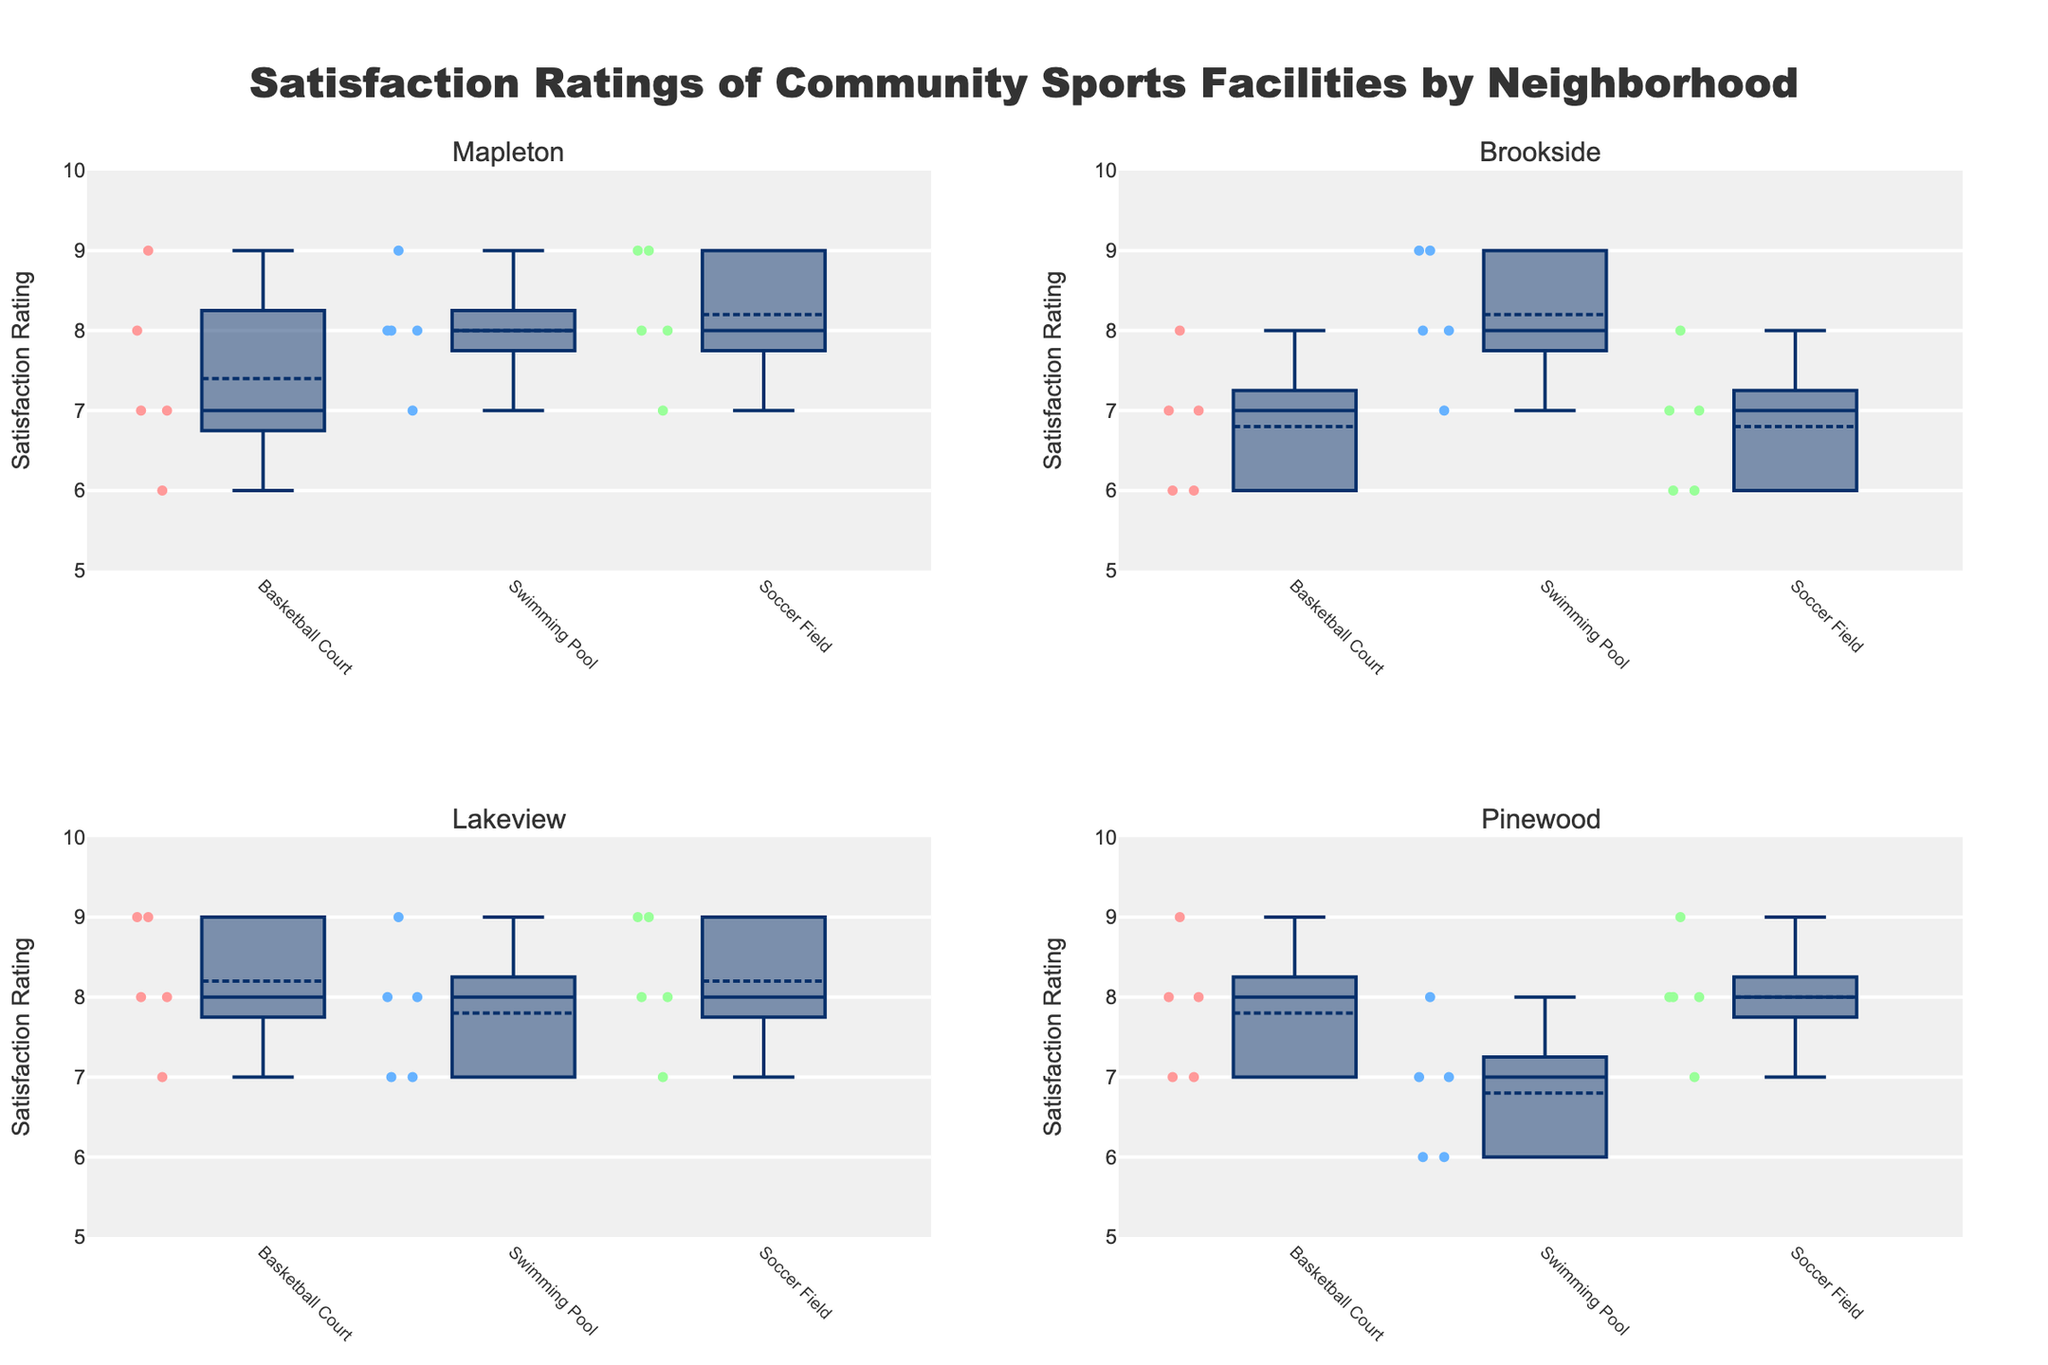Which neighborhood has the highest median satisfaction rating for Basketball Courts? First, locate the box plots for Basketball Courts in each neighborhood. Then, identify and compare the median values (shown by the line inside each box).
Answer: Lakeview What is the range of satisfaction ratings for the Swimming Pool in Mapleton? Find the box plot for the Swimming Pool in Mapleton. The range is the difference between the maximum and minimum values observed, represented by the top and bottom whiskers.
Answer: 7-9 How do the median satisfaction ratings of Soccer Fields compare between Brookside and Pinewood? Locate the box plots for Soccer Fields in Brookside and Pinewood and compare the medians (the lines inside the boxes).
Answer: Brookside's median is lower Which facility in Lakeview has the lowest maximum satisfaction rating, and what is that rating? Look at all the box plots for facilities in Lakeview and examine the maximum values (top whisker) to find the lowest one.
Answer: Swimming Pool, 9 Which neighborhood has the most consistent satisfaction ratings for its Swimming Pool? Consistency can be seen in the box's interquartile range (IQR). The smaller the IQR, the more consistent the ratings. Compare the IQRs for Swimming Pools across neighborhoods.
Answer: Lakeview Does Pinewood or Mapleton have a higher overall satisfaction with Soccer Fields, considering median values? Find the median satisfaction ratings for Soccer Fields in Pinewood and Mapleton (lines inside the boxes) and compare them.
Answer: They are equal Which facility has the smallest range of satisfaction ratings in Pinewood? Examine the box plots for Pinewood's facilities and compare the ranges (difference between maximum and minimum values).
Answer: Swimming Pool Which facility in Mapleton has the highest variability in satisfaction ratings? Variability can be viewed by the IQR of each facility. The wider the IQR, the more variable the ratings. Compare this for each facility in Mapleton.
Answer: Basketball Court How do the satisfaction ratings for Swimming Pool in Pinewood vary compared to Brookside? Compare the box plots for Swimming Pools in Pinewood and Brookside by examining the median, IQR, and whiskers.
Answer: Brookside has higher median and lower variability 